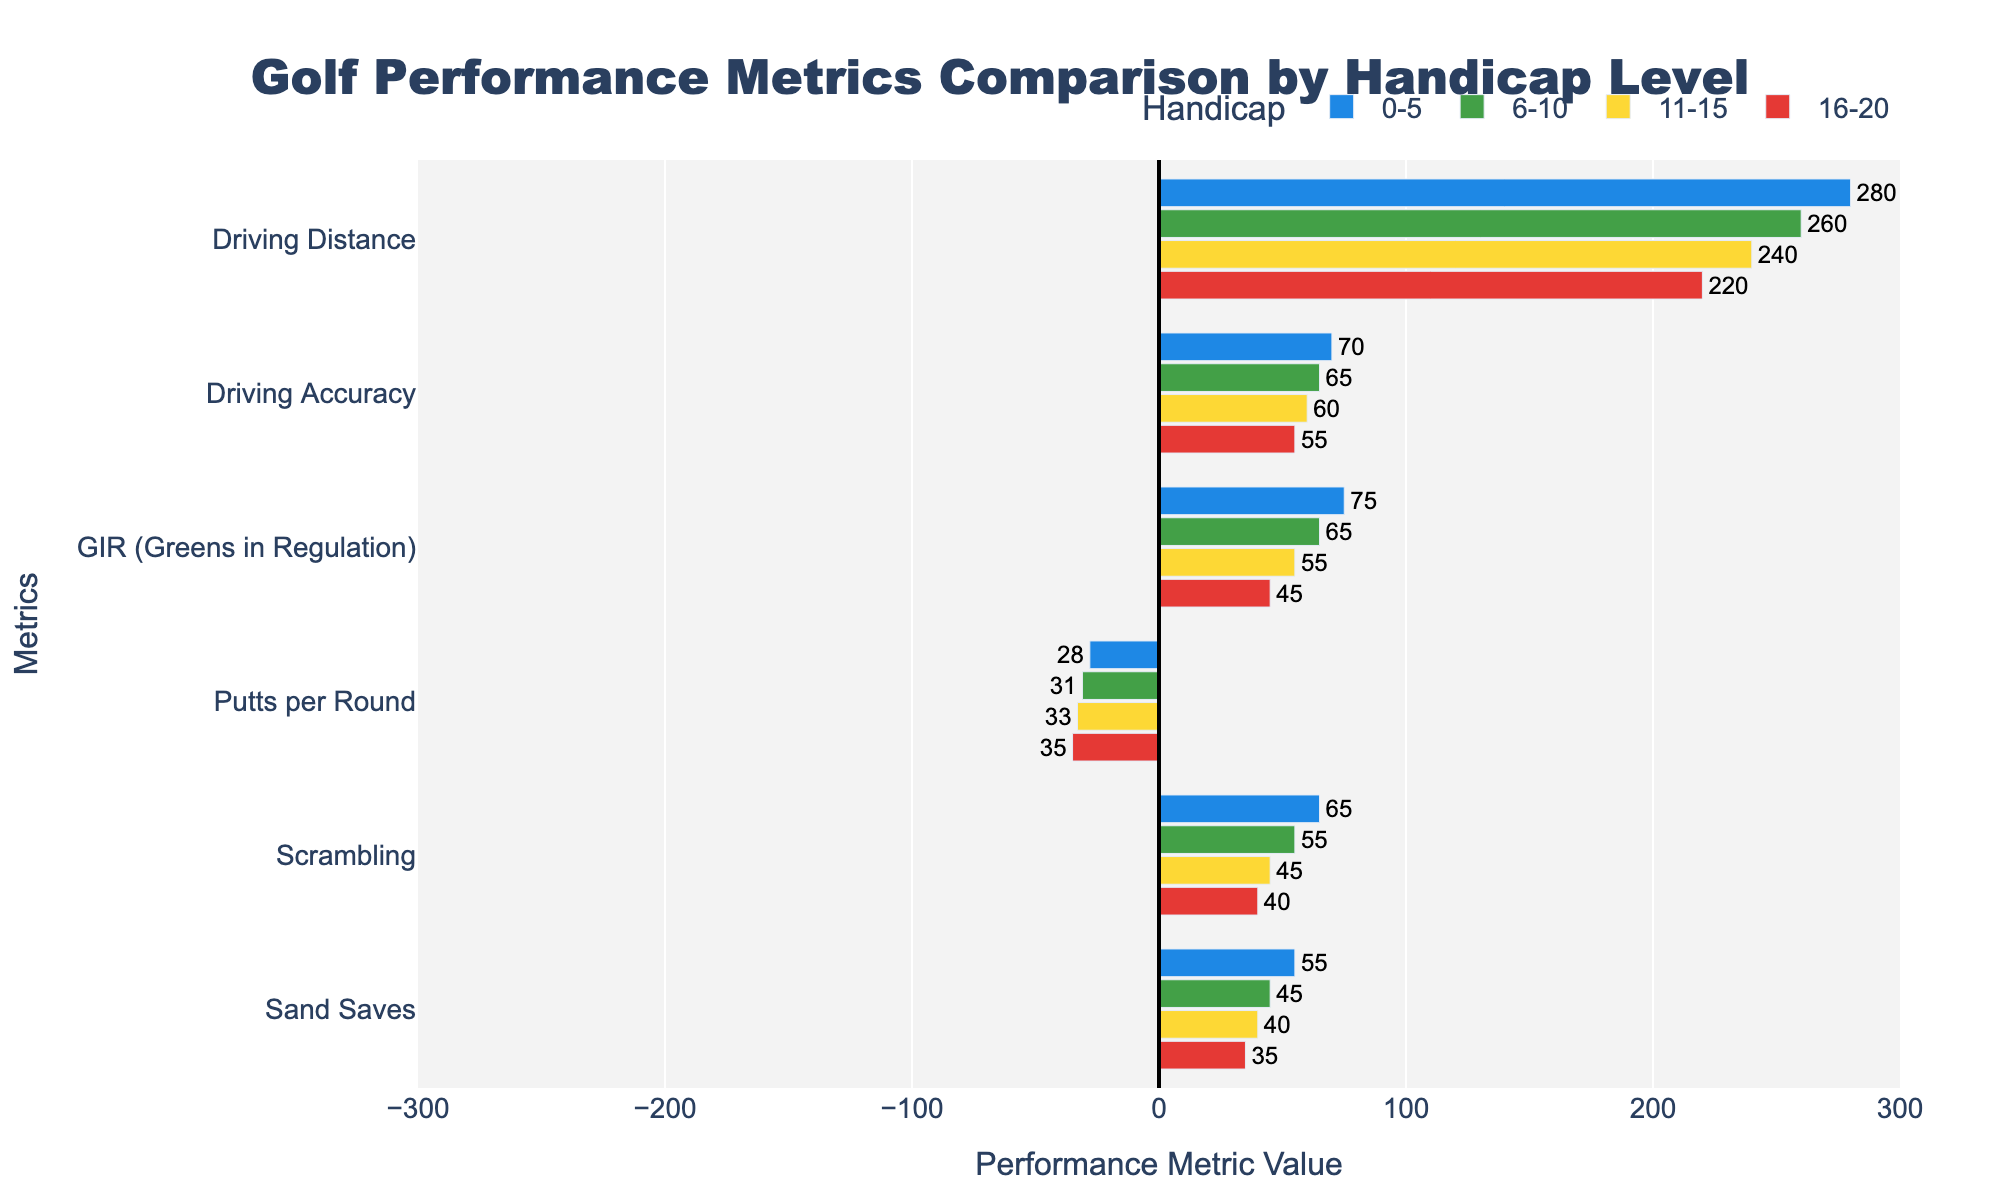Which handicap level has the highest driving distance? Inspect the bars representing 'Driving Distance' for all handicap levels. The longest bar belongs to the '0-5' handicap level.
Answer: 0-5 How much more driving distance do golfers with a 0-5 handicap have compared to those with 16-20 handicaps? Look at the 'Driving Distance' values for both handicap levels. The value for 0-5 is 280, and for 16-20 is 220. The difference is 280 - 220 = 60.
Answer: 60 Which metric shows the most significant decrease as the handicap level increases, from 0-5 to 16-20? Compare the values of each metric for the 0-5 and 16-20 handicap levels. The metric with the largest difference is 'Driving Distance' (280 to 220), which is a decrease of 60.
Answer: Driving Distance What is the average 'Putts per Round' value across all handicap levels? Find and sum the 'Putts per Round' values: 28 + 31 + 33 + 35 = 127. Divide by the number of handicap levels (4). So, 127 / 4 = 31.75
Answer: 31.75 Is driving accuracy significantly different between the 0-5 and 6-10 handicap levels? Compare the 'Driving Accuracy' values for 0-5 (70) and 6-10 (65). The difference is 70 - 65 = 5, which is relatively small.
Answer: No Which handicap level has the lowest scrambling performance? Compare the 'Scrambling' values across all handicap levels. The lowest value is 40, which is in the 16-20 handicap level.
Answer: 16-20 By how many units do the 11-15 golfers outperform the 16-20 golfers in 'GIR (Greens in Regulation)'? Compare the 'GIR' values for 11-15 (55) and 16-20 (45). The difference is 55 - 45 = 10.
Answer: 10 What color represents the 6-10 handicap level? Identify the color associated with the 6-10 handicap level by the bars' color. It is green.
Answer: Green Which metric has the smallest variation across all handicap levels? Observe each metric's values across the handicap levels and calculate the range. 'Putts per Round' varies from 28 to 35, a difference of 7, which is the smallest among the metrics.
Answer: Putts per Round Do golfers with a 0-5 handicap have better sand saves performance than those with 11-15 handicaps? Compare 'Sand Saves' values for 0-5 (55) and 11-15 (40). The 0-5 handicap level has a higher value.
Answer: Yes 